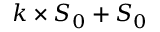Convert formula to latex. <formula><loc_0><loc_0><loc_500><loc_500>k \times S _ { 0 } + S _ { 0 }</formula> 